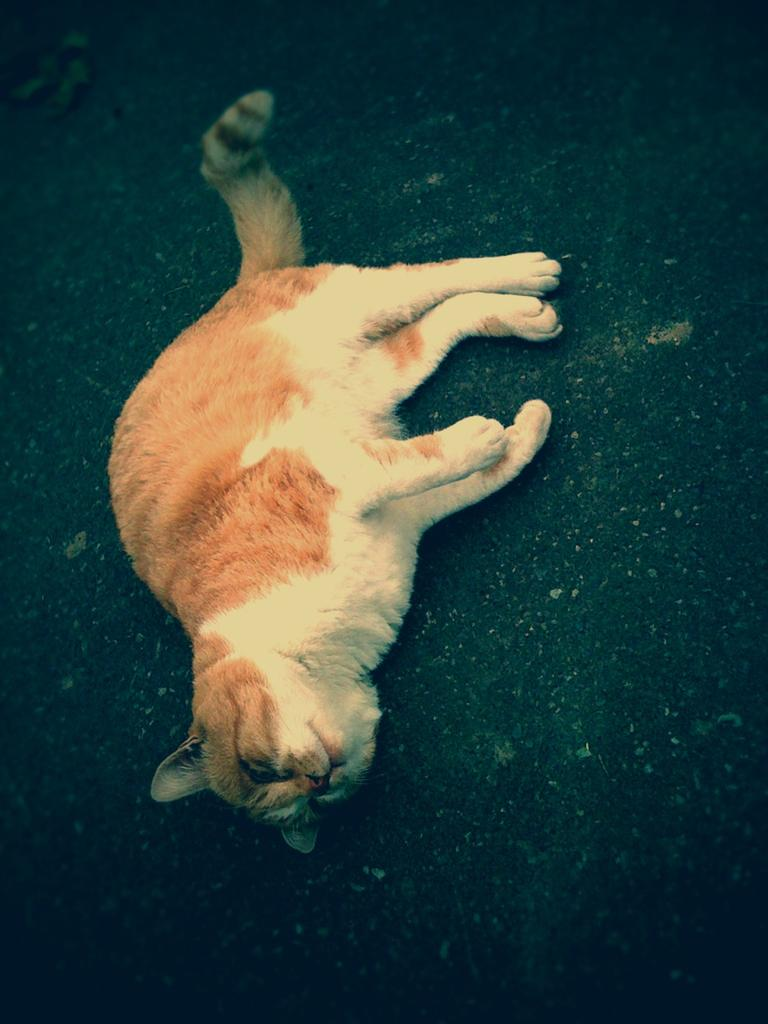What type of animal is in the image? There is a cat in the image. What is the cat doing in the image? The cat is lying on the floor. What type of fowl is present in the image? There is no fowl present in the image; it only features a cat lying on the floor. 